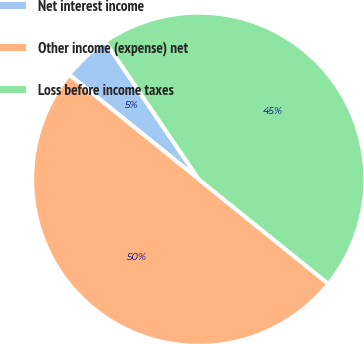Convert chart. <chart><loc_0><loc_0><loc_500><loc_500><pie_chart><fcel>Net interest income<fcel>Other income (expense) net<fcel>Loss before income taxes<nl><fcel>4.69%<fcel>50.0%<fcel>45.31%<nl></chart> 